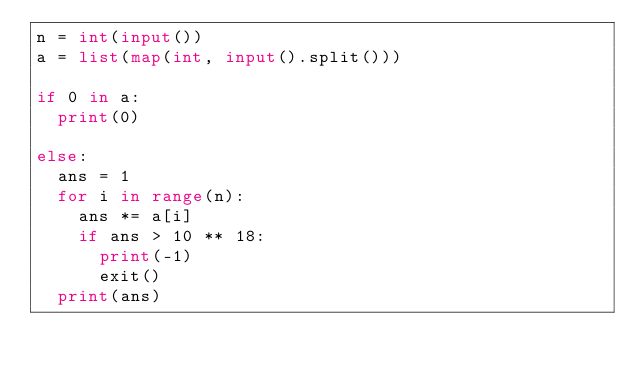<code> <loc_0><loc_0><loc_500><loc_500><_Python_>n = int(input())
a = list(map(int, input().split()))

if 0 in a:
  print(0)

else:
  ans = 1
  for i in range(n):
    ans *= a[i]
    if ans > 10 ** 18:
      print(-1)
      exit()
  print(ans)</code> 